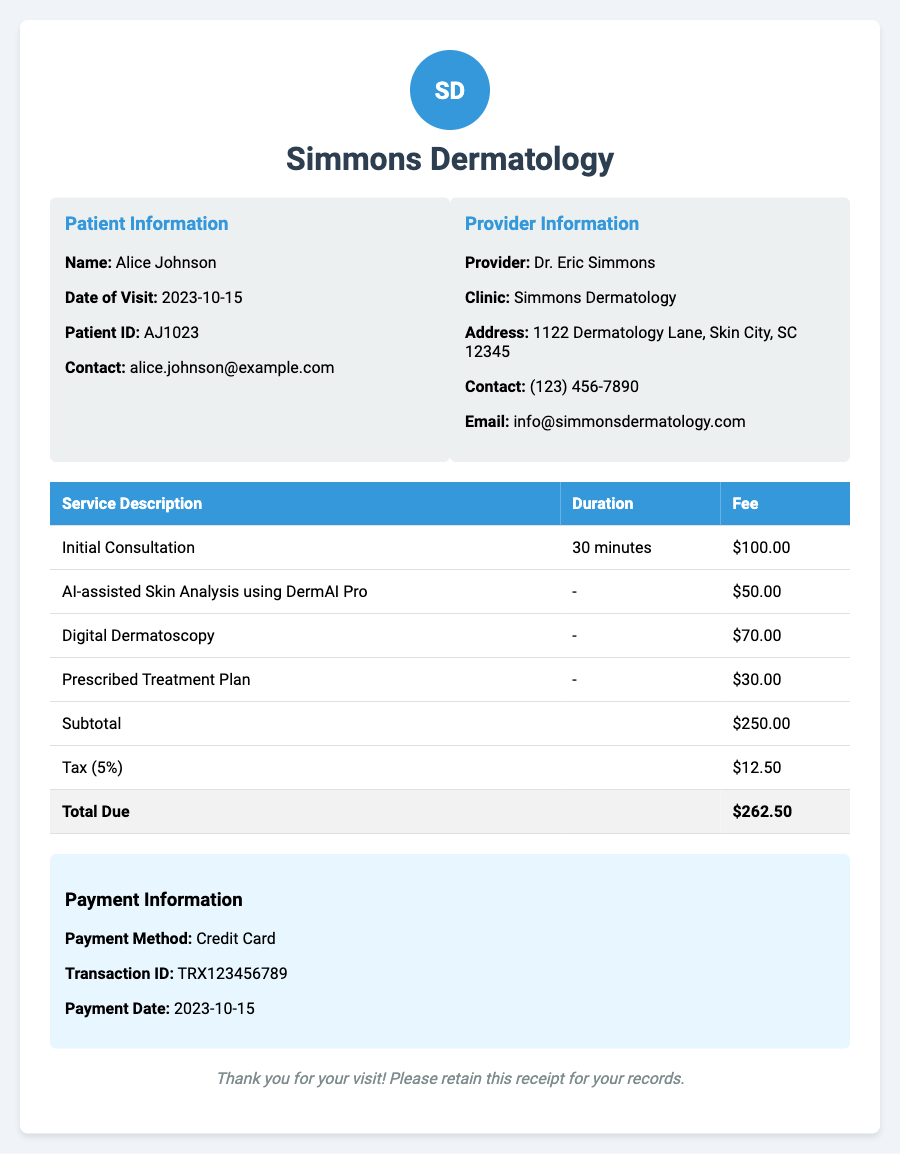What is the patient's name? The patient's name is listed in the Patient Information section of the document.
Answer: Alice Johnson What services are included in the receipt? The services rendered are detailed in the table, listing each service type.
Answer: Initial Consultation, AI-assisted Skin Analysis using DermAI Pro, Digital Dermatoscopy, Prescribed Treatment Plan What is the total due amount? The document clearly states the total amount due at the bottom of the table.
Answer: $262.50 What was the payment method used? The payment information section specifies the method used for payment.
Answer: Credit Card What is the tax percentage applied? The receipt mentions the tax rate applied to the subtotal for calculation purposes.
Answer: 5% How long is the initial consultation? The duration of the initial consultation is listed under the service description.
Answer: 30 minutes What AI tool was used during the consultation? The receipt specifically names the AI tool utilized for skin analysis.
Answer: DermAI Pro When did the patient's visit occur? The date of the visit is indicated in the Patient Information section.
Answer: 2023-10-15 What is the provider's contact number? The provider's contact information is given under the Provider Information section.
Answer: (123) 456-7890 